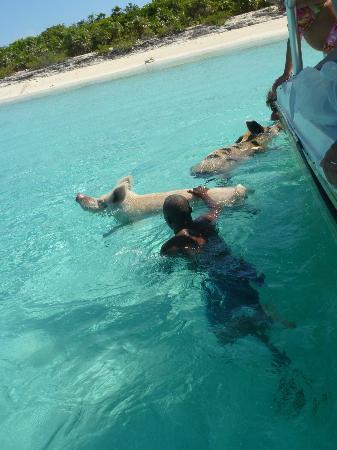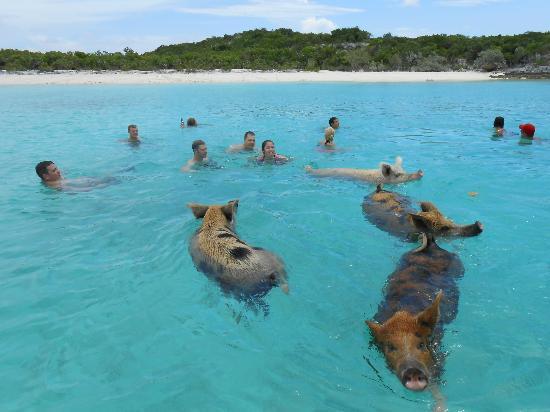The first image is the image on the left, the second image is the image on the right. Considering the images on both sides, is "Each image shows two pigs swimming in a body of water, and in at least one image, the pigs' snouts face opposite directions." valid? Answer yes or no. No. The first image is the image on the left, the second image is the image on the right. Examine the images to the left and right. Is the description "There are exactly four pigs swimming." accurate? Answer yes or no. No. 